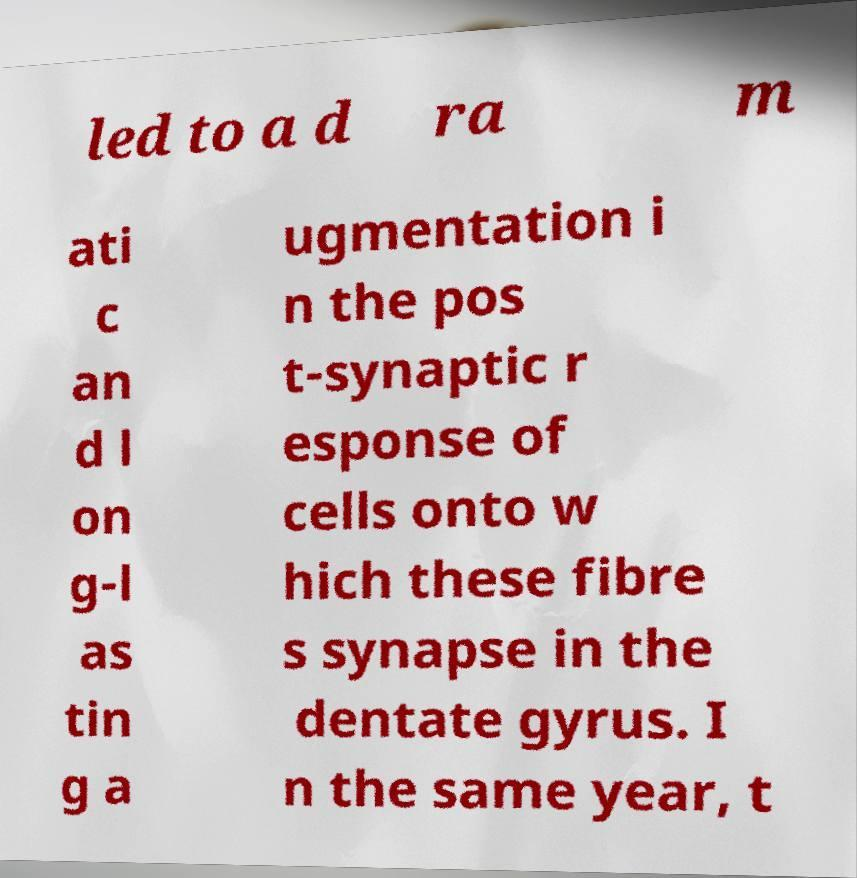Can you read and provide the text displayed in the image?This photo seems to have some interesting text. Can you extract and type it out for me? led to a d ra m ati c an d l on g-l as tin g a ugmentation i n the pos t-synaptic r esponse of cells onto w hich these fibre s synapse in the dentate gyrus. I n the same year, t 